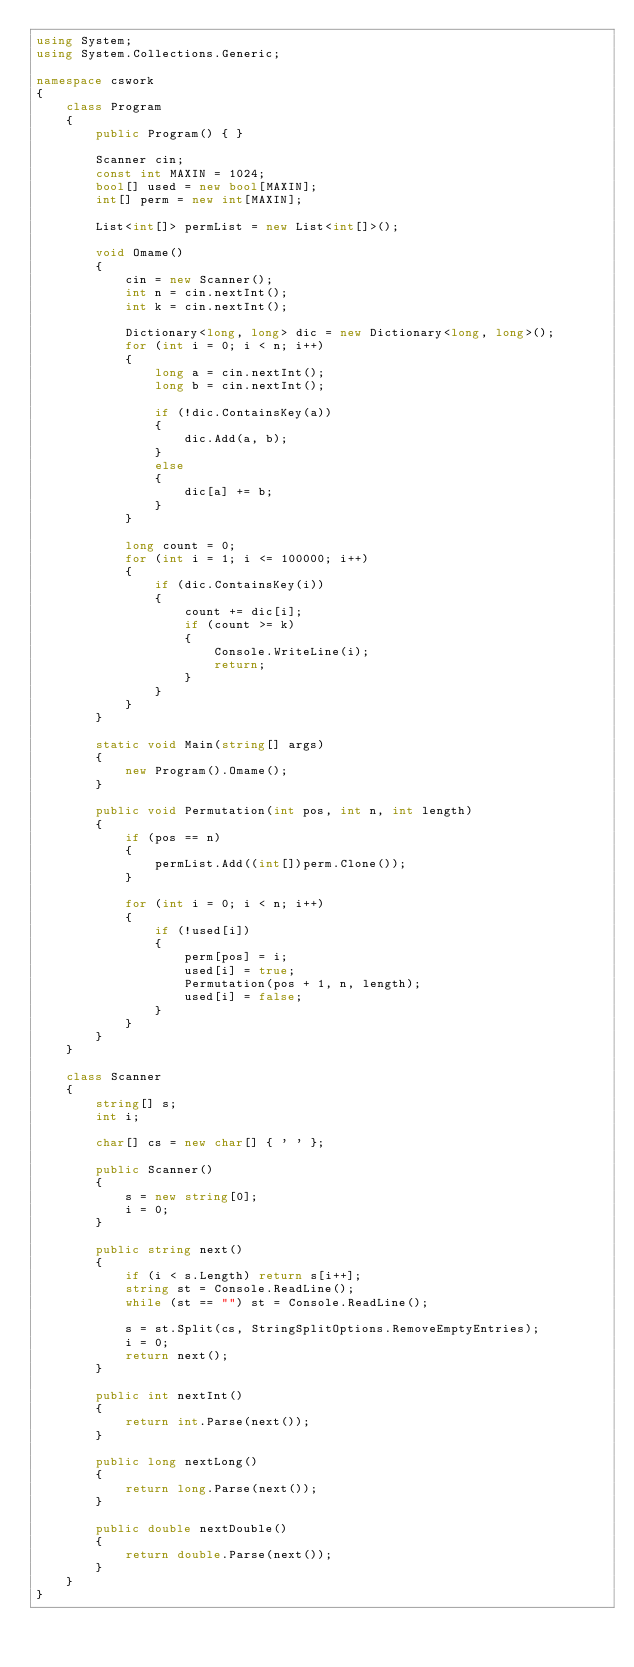<code> <loc_0><loc_0><loc_500><loc_500><_C#_>using System;
using System.Collections.Generic;

namespace cswork
{
    class Program
    {
        public Program() { }

        Scanner cin;
        const int MAXIN = 1024;
        bool[] used = new bool[MAXIN];
        int[] perm = new int[MAXIN];

        List<int[]> permList = new List<int[]>();

        void Omame()
        {
            cin = new Scanner();
            int n = cin.nextInt();
            int k = cin.nextInt();

            Dictionary<long, long> dic = new Dictionary<long, long>();
            for (int i = 0; i < n; i++)
            {
                long a = cin.nextInt();
                long b = cin.nextInt();

                if (!dic.ContainsKey(a))
                {
                    dic.Add(a, b);
                }
                else
                {
                    dic[a] += b;
                }
            }

            long count = 0;
            for (int i = 1; i <= 100000; i++)
            {
                if (dic.ContainsKey(i))
                {
                    count += dic[i];
                    if (count >= k)
                    {
                        Console.WriteLine(i);
                        return;
                    }
                }
            }
        }

        static void Main(string[] args)
        {
            new Program().Omame();
        }

        public void Permutation(int pos, int n, int length)
        {
            if (pos == n)
            {
                permList.Add((int[])perm.Clone());
            }

            for (int i = 0; i < n; i++)
            {
                if (!used[i])
                {
                    perm[pos] = i;
                    used[i] = true;
                    Permutation(pos + 1, n, length);
                    used[i] = false;
                }
            }
        }
    }

    class Scanner
    {
        string[] s;
        int i;

        char[] cs = new char[] { ' ' };

        public Scanner()
        {
            s = new string[0];
            i = 0;
        }

        public string next()
        {
            if (i < s.Length) return s[i++];
            string st = Console.ReadLine();
            while (st == "") st = Console.ReadLine();

            s = st.Split(cs, StringSplitOptions.RemoveEmptyEntries);
            i = 0;
            return next();
        }

        public int nextInt()
        {
            return int.Parse(next());
        }

        public long nextLong()
        {
            return long.Parse(next());
        }

        public double nextDouble()
        {
            return double.Parse(next());
        }
    }
}</code> 